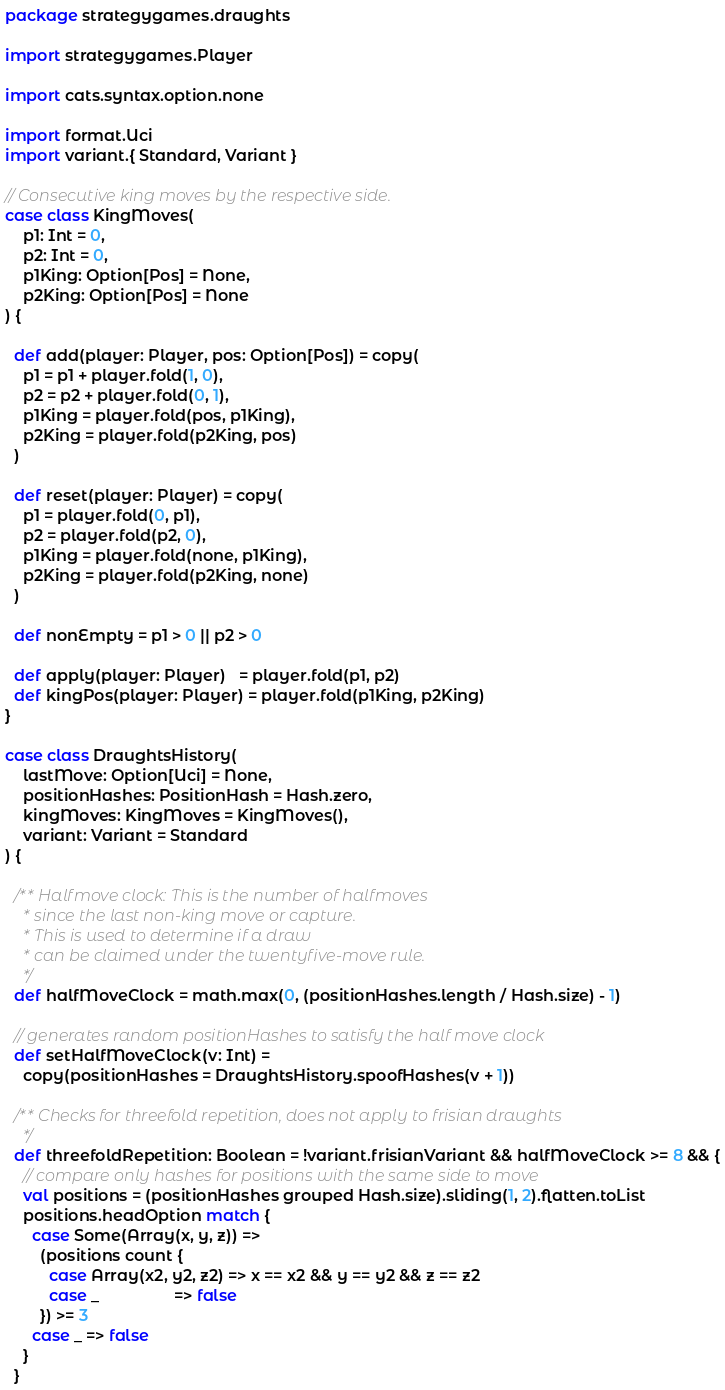Convert code to text. <code><loc_0><loc_0><loc_500><loc_500><_Scala_>package strategygames.draughts

import strategygames.Player

import cats.syntax.option.none

import format.Uci
import variant.{ Standard, Variant }

// Consecutive king moves by the respective side.
case class KingMoves(
    p1: Int = 0,
    p2: Int = 0,
    p1King: Option[Pos] = None,
    p2King: Option[Pos] = None
) {

  def add(player: Player, pos: Option[Pos]) = copy(
    p1 = p1 + player.fold(1, 0),
    p2 = p2 + player.fold(0, 1),
    p1King = player.fold(pos, p1King),
    p2King = player.fold(p2King, pos)
  )

  def reset(player: Player) = copy(
    p1 = player.fold(0, p1),
    p2 = player.fold(p2, 0),
    p1King = player.fold(none, p1King),
    p2King = player.fold(p2King, none)
  )

  def nonEmpty = p1 > 0 || p2 > 0

  def apply(player: Player)   = player.fold(p1, p2)
  def kingPos(player: Player) = player.fold(p1King, p2King)
}

case class DraughtsHistory(
    lastMove: Option[Uci] = None,
    positionHashes: PositionHash = Hash.zero,
    kingMoves: KingMoves = KingMoves(),
    variant: Variant = Standard
) {

  /** Halfmove clock: This is the number of halfmoves
    * since the last non-king move or capture.
    * This is used to determine if a draw
    * can be claimed under the twentyfive-move rule.
    */
  def halfMoveClock = math.max(0, (positionHashes.length / Hash.size) - 1)

  // generates random positionHashes to satisfy the half move clock
  def setHalfMoveClock(v: Int) =
    copy(positionHashes = DraughtsHistory.spoofHashes(v + 1))

  /** Checks for threefold repetition, does not apply to frisian draughts
    */
  def threefoldRepetition: Boolean = !variant.frisianVariant && halfMoveClock >= 8 && {
    // compare only hashes for positions with the same side to move
    val positions = (positionHashes grouped Hash.size).sliding(1, 2).flatten.toList
    positions.headOption match {
      case Some(Array(x, y, z)) =>
        (positions count {
          case Array(x2, y2, z2) => x == x2 && y == y2 && z == z2
          case _                 => false
        }) >= 3
      case _ => false
    }
  }
</code> 